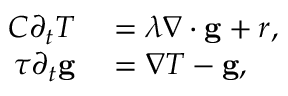<formula> <loc_0><loc_0><loc_500><loc_500>\begin{array} { r l } { C \partial _ { t } T } & = \lambda \nabla \cdot \mathbf g + r , } \\ { \tau \partial _ { t } \mathbf g } & = \nabla T - \mathbf g , } \end{array}</formula> 